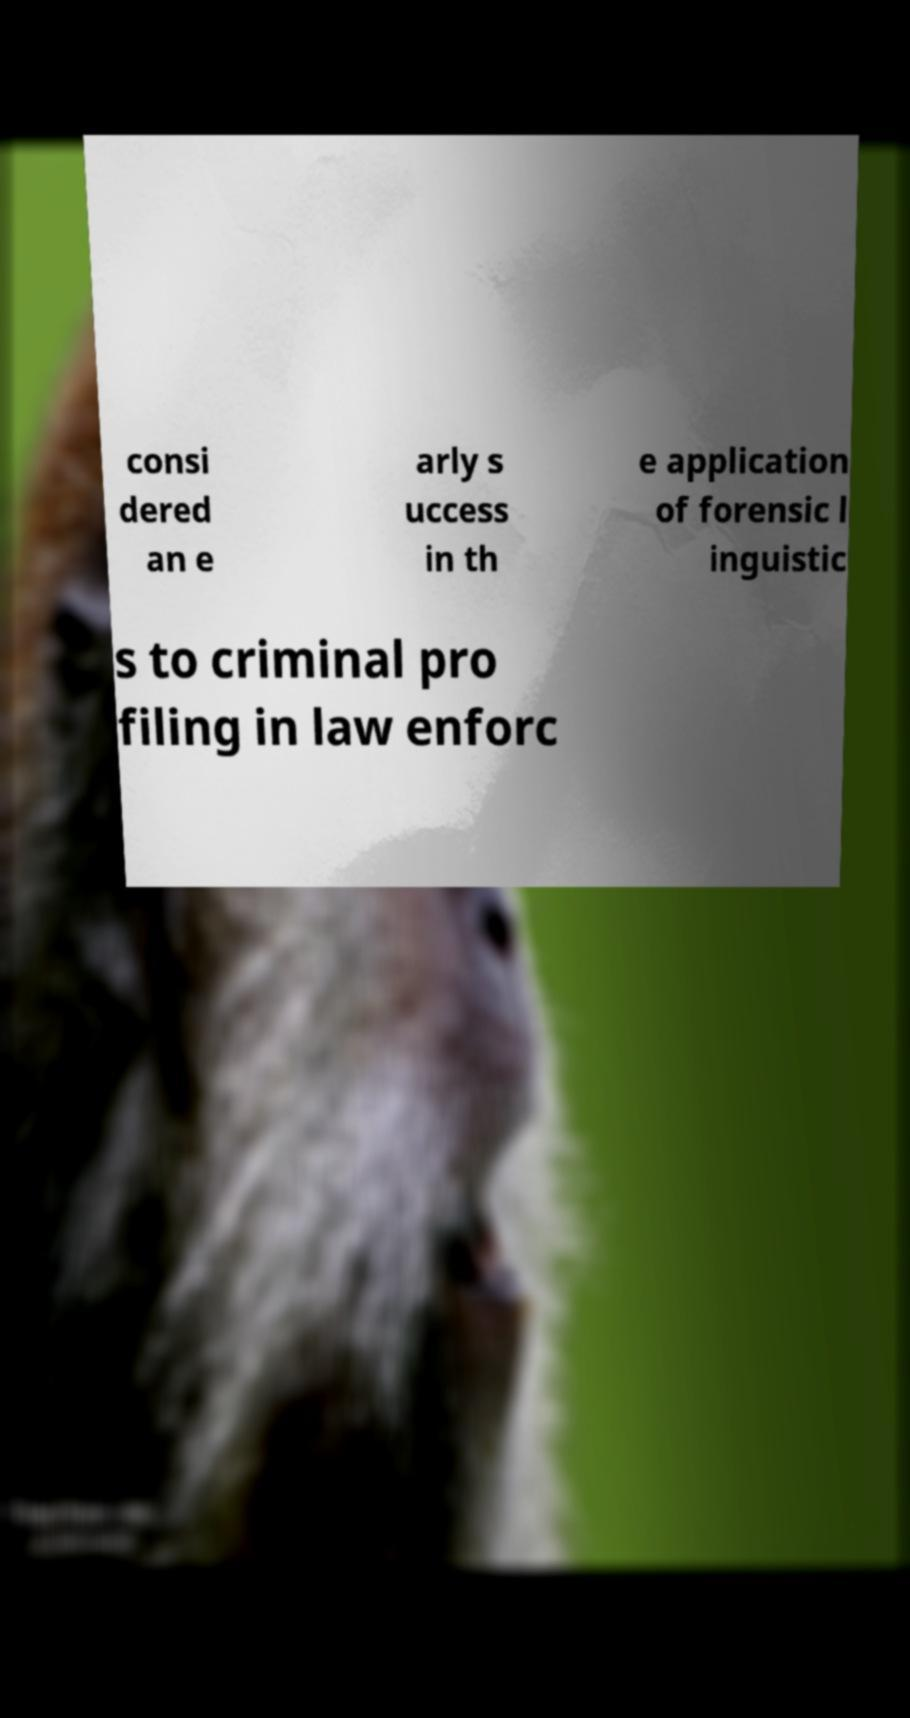Could you assist in decoding the text presented in this image and type it out clearly? consi dered an e arly s uccess in th e application of forensic l inguistic s to criminal pro filing in law enforc 